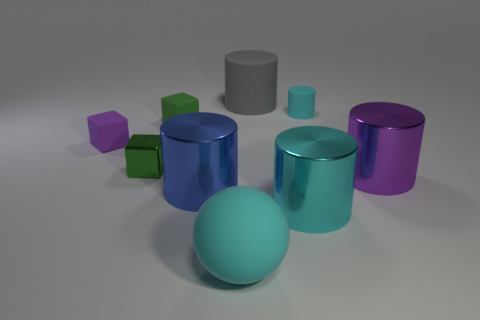Subtract 2 cylinders. How many cylinders are left? 3 Subtract all small cyan rubber cylinders. How many cylinders are left? 4 Subtract all gray cylinders. How many cylinders are left? 4 Subtract all red cylinders. Subtract all red blocks. How many cylinders are left? 5 Subtract all balls. How many objects are left? 8 Subtract 1 green blocks. How many objects are left? 8 Subtract all big metallic things. Subtract all blue metal objects. How many objects are left? 5 Add 8 big matte things. How many big matte things are left? 10 Add 3 big brown shiny things. How many big brown shiny things exist? 3 